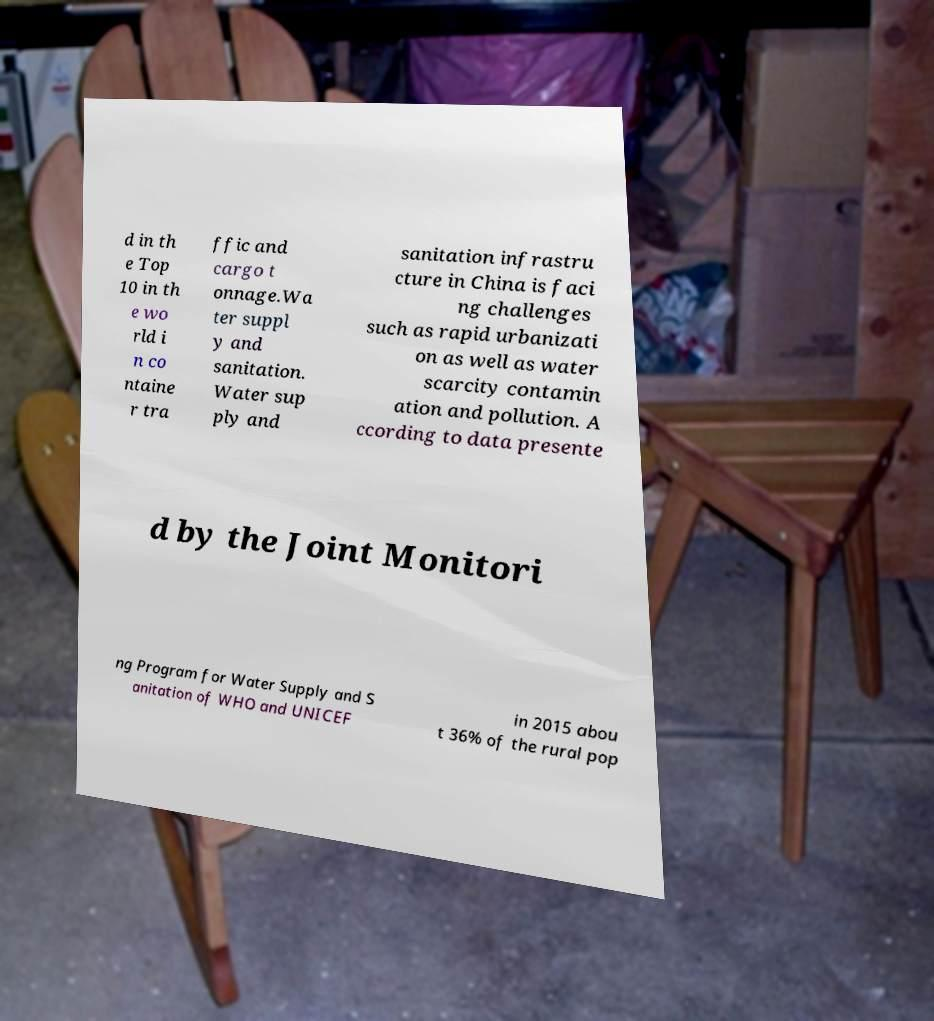Can you read and provide the text displayed in the image?This photo seems to have some interesting text. Can you extract and type it out for me? d in th e Top 10 in th e wo rld i n co ntaine r tra ffic and cargo t onnage.Wa ter suppl y and sanitation. Water sup ply and sanitation infrastru cture in China is faci ng challenges such as rapid urbanizati on as well as water scarcity contamin ation and pollution. A ccording to data presente d by the Joint Monitori ng Program for Water Supply and S anitation of WHO and UNICEF in 2015 abou t 36% of the rural pop 